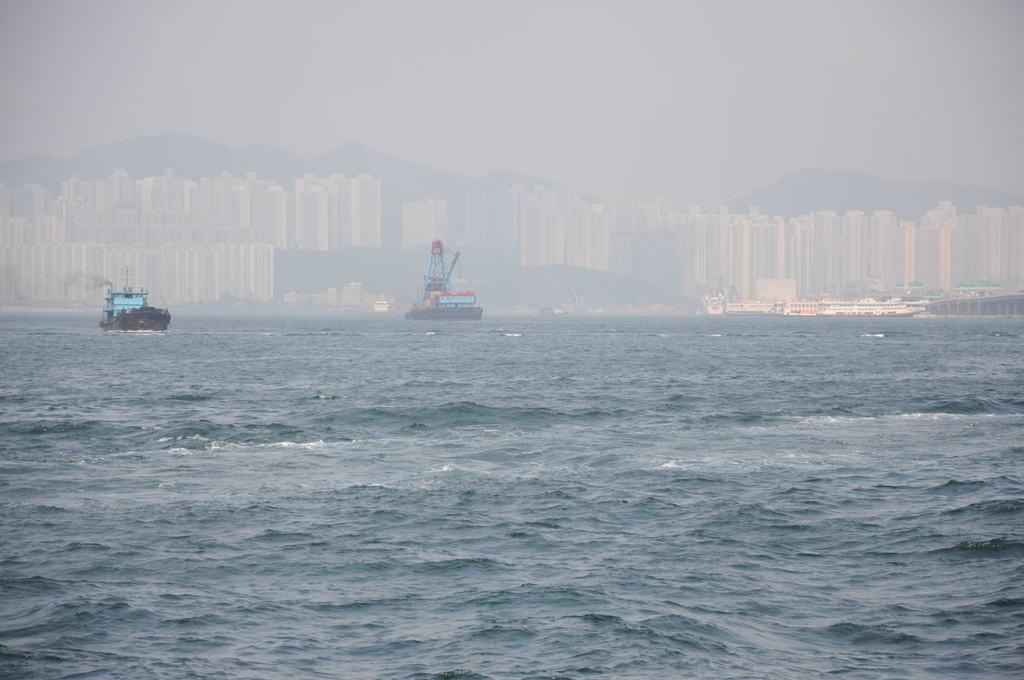What is in the front of the image? There is water in the front of the image. What is on the water? There are two boats on the water. What can be seen in the background of the image? There are buildings in the background of the image. What type of competition is taking place in the image? There is no competition present in the image; it features water, two boats, and buildings in the background. What time is it according to the clock in the image? There is no clock present in the image. 